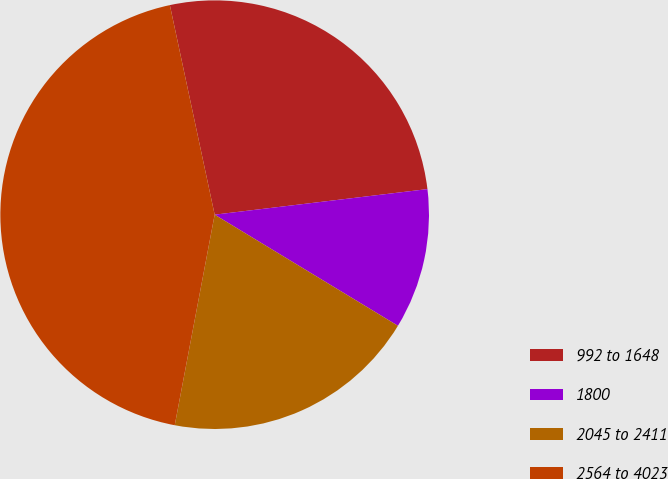Convert chart. <chart><loc_0><loc_0><loc_500><loc_500><pie_chart><fcel>992 to 1648<fcel>1800<fcel>2045 to 2411<fcel>2564 to 4023<nl><fcel>26.45%<fcel>10.58%<fcel>19.31%<fcel>43.67%<nl></chart> 